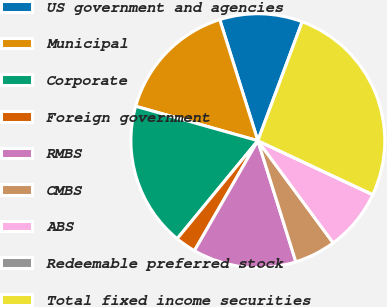Convert chart to OTSL. <chart><loc_0><loc_0><loc_500><loc_500><pie_chart><fcel>US government and agencies<fcel>Municipal<fcel>Corporate<fcel>Foreign government<fcel>RMBS<fcel>CMBS<fcel>ABS<fcel>Redeemable preferred stock<fcel>Total fixed income securities<nl><fcel>10.53%<fcel>15.78%<fcel>18.41%<fcel>2.64%<fcel>13.16%<fcel>5.27%<fcel>7.9%<fcel>0.01%<fcel>26.3%<nl></chart> 